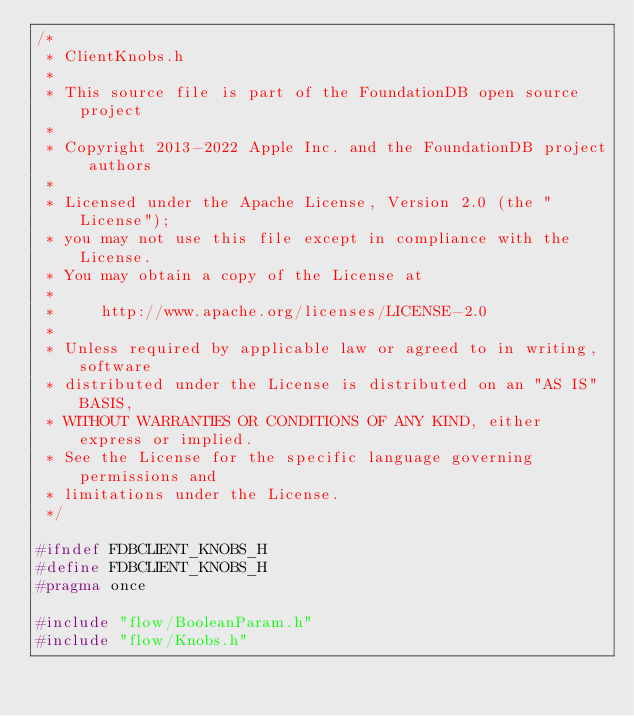<code> <loc_0><loc_0><loc_500><loc_500><_C_>/*
 * ClientKnobs.h
 *
 * This source file is part of the FoundationDB open source project
 *
 * Copyright 2013-2022 Apple Inc. and the FoundationDB project authors
 *
 * Licensed under the Apache License, Version 2.0 (the "License");
 * you may not use this file except in compliance with the License.
 * You may obtain a copy of the License at
 *
 *     http://www.apache.org/licenses/LICENSE-2.0
 *
 * Unless required by applicable law or agreed to in writing, software
 * distributed under the License is distributed on an "AS IS" BASIS,
 * WITHOUT WARRANTIES OR CONDITIONS OF ANY KIND, either express or implied.
 * See the License for the specific language governing permissions and
 * limitations under the License.
 */

#ifndef FDBCLIENT_KNOBS_H
#define FDBCLIENT_KNOBS_H
#pragma once

#include "flow/BooleanParam.h"
#include "flow/Knobs.h"</code> 